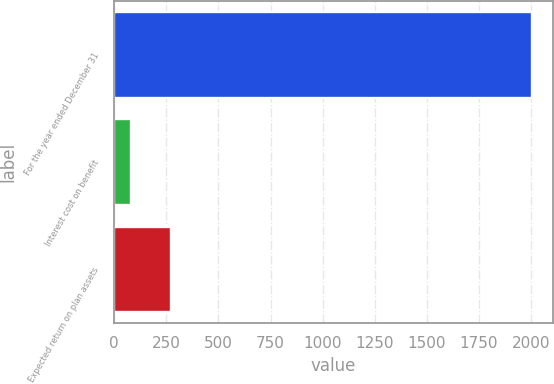Convert chart to OTSL. <chart><loc_0><loc_0><loc_500><loc_500><bar_chart><fcel>For the year ended December 31<fcel>Interest cost on benefit<fcel>Expected return on plan assets<nl><fcel>2004<fcel>81<fcel>273.3<nl></chart> 